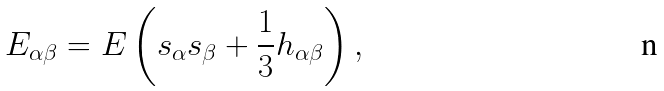<formula> <loc_0><loc_0><loc_500><loc_500>E _ { \alpha \beta } = E \left ( s _ { \alpha } s _ { \beta } + \frac { 1 } { 3 } h _ { \alpha \beta } \right ) ,</formula> 